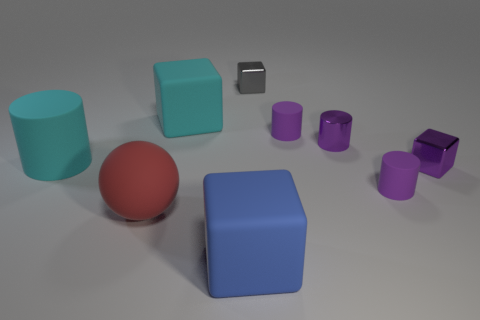What material do the cylinder objects in the image appear to be made of? The cylindrical objects present in the image give off a reflective quality, implying that they are likely to be constructed of a metallic material. Their sheen and the way light interacts with their surfaces support this observation. 